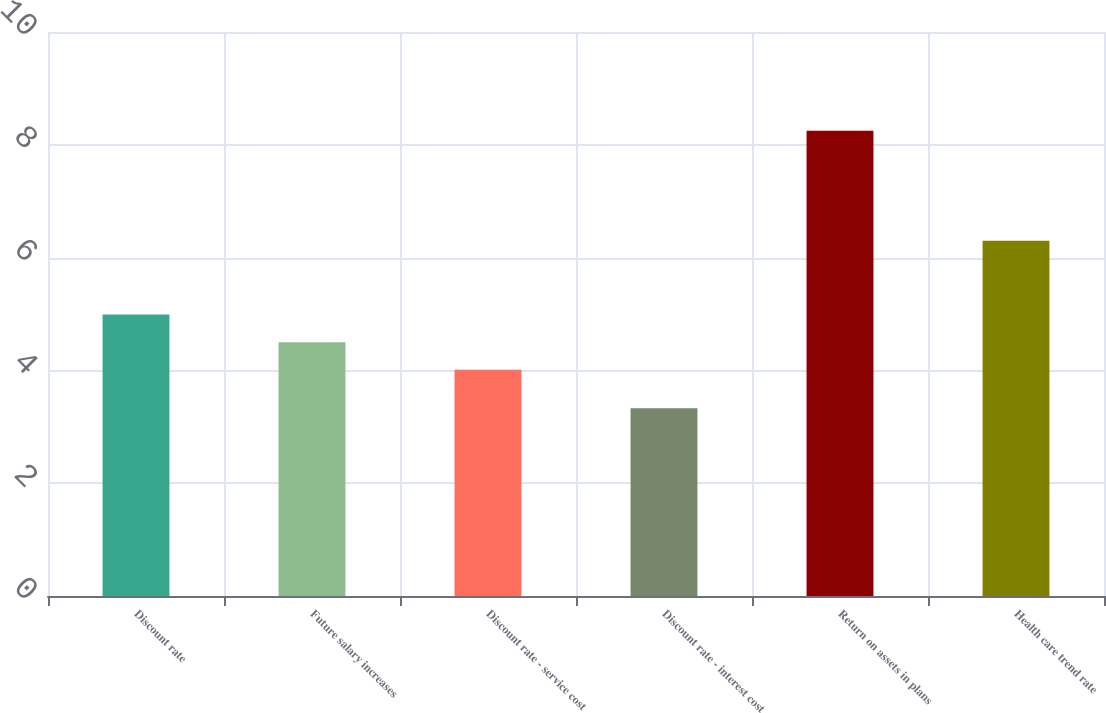Convert chart to OTSL. <chart><loc_0><loc_0><loc_500><loc_500><bar_chart><fcel>Discount rate<fcel>Future salary increases<fcel>Discount rate - service cost<fcel>Discount rate - interest cost<fcel>Return on assets in plans<fcel>Health care trend rate<nl><fcel>4.99<fcel>4.5<fcel>4.01<fcel>3.33<fcel>8.25<fcel>6.3<nl></chart> 